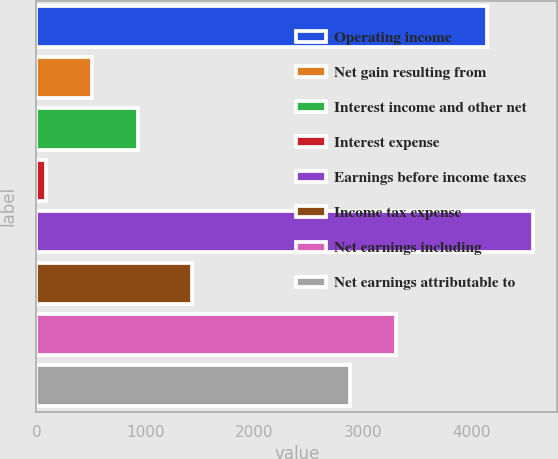Convert chart to OTSL. <chart><loc_0><loc_0><loc_500><loc_500><bar_chart><fcel>Operating income<fcel>Net gain resulting from<fcel>Interest income and other net<fcel>Interest expense<fcel>Earnings before income taxes<fcel>Income tax expense<fcel>Net earnings including<fcel>Net earnings attributable to<nl><fcel>4134.7<fcel>515<fcel>937.5<fcel>92.5<fcel>4557.2<fcel>1432.6<fcel>3307.2<fcel>2884.7<nl></chart> 